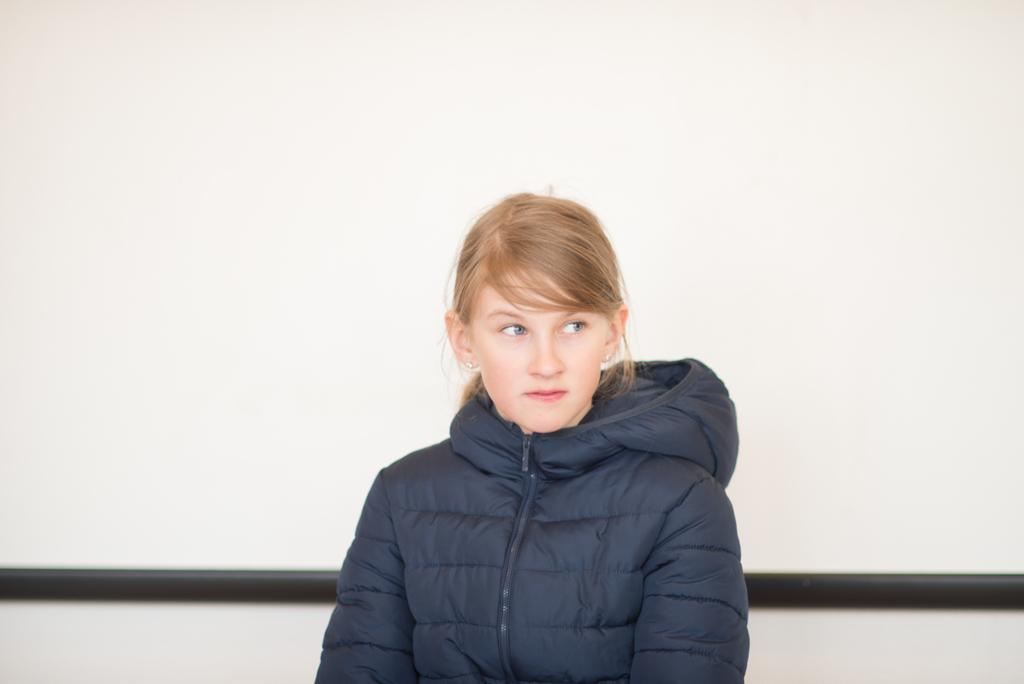What is the main subject of the image? There is a person standing in the image. What is the person wearing in the image? The person is wearing a blue jacket. What color is the background of the image? The background of the image is white. Is the thumb visible in the image? There is no thumb present in the image. Is the person wearing a mask in the image? There is no mask visible on the person in the image. 